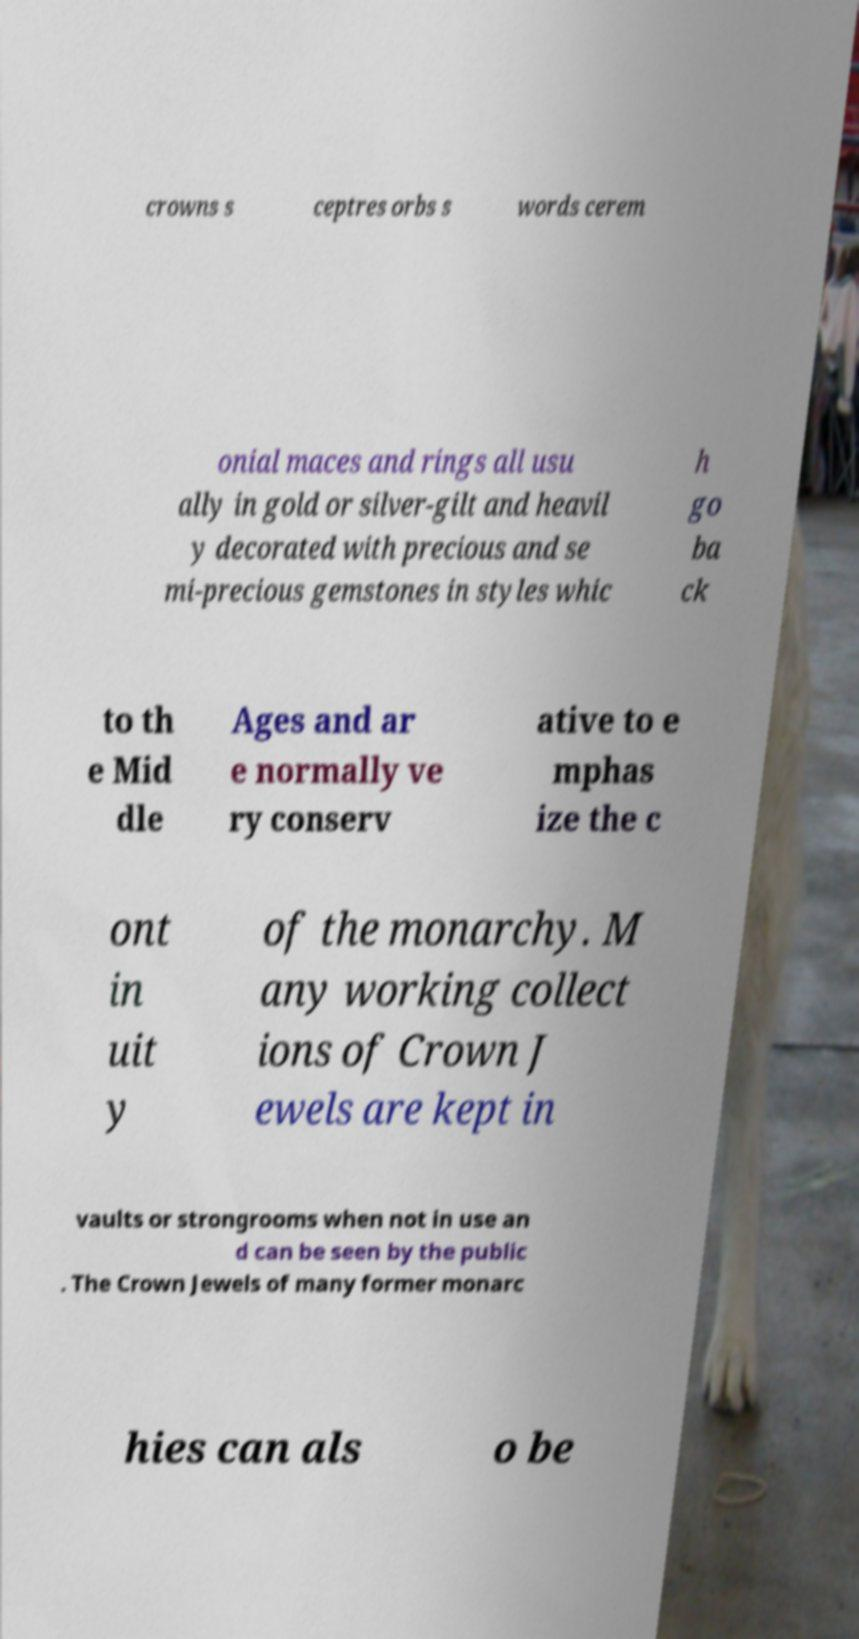For documentation purposes, I need the text within this image transcribed. Could you provide that? crowns s ceptres orbs s words cerem onial maces and rings all usu ally in gold or silver-gilt and heavil y decorated with precious and se mi-precious gemstones in styles whic h go ba ck to th e Mid dle Ages and ar e normally ve ry conserv ative to e mphas ize the c ont in uit y of the monarchy. M any working collect ions of Crown J ewels are kept in vaults or strongrooms when not in use an d can be seen by the public . The Crown Jewels of many former monarc hies can als o be 